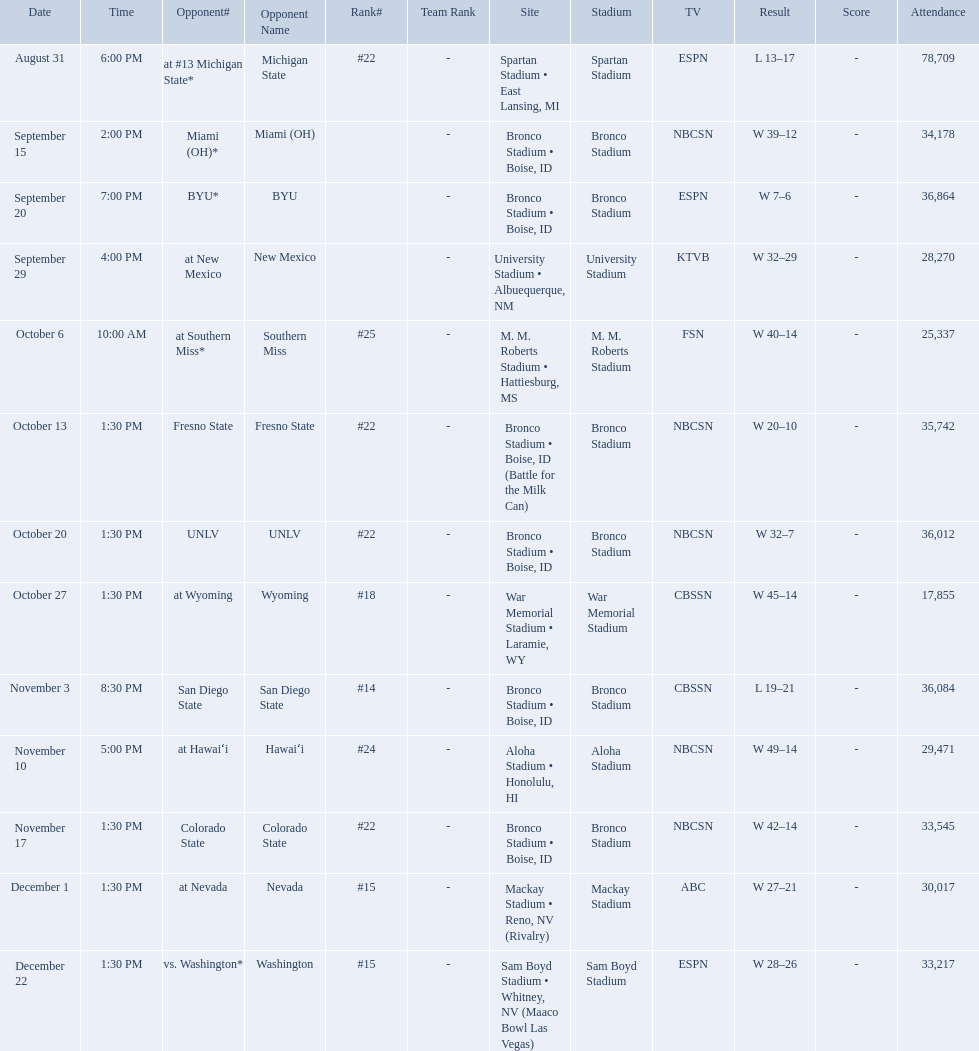What was the team's listed rankings for the season? #22, , , , #25, #22, #22, #18, #14, #24, #22, #15, #15. Which of these ranks is the best? #14. Who were all of the opponents? At #13 michigan state*, miami (oh)*, byu*, at new mexico, at southern miss*, fresno state, unlv, at wyoming, san diego state, at hawaiʻi, colorado state, at nevada, vs. washington*. Who did they face on november 3rd? San Diego State. What rank were they on november 3rd? #14. What are the opponents to the  2012 boise state broncos football team? At #13 michigan state*, miami (oh)*, byu*, at new mexico, at southern miss*, fresno state, unlv, at wyoming, san diego state, at hawaiʻi, colorado state, at nevada, vs. washington*. Which is the highest ranked of the teams? San Diego State. Who were all the opponents for boise state? At #13 michigan state*, miami (oh)*, byu*, at new mexico, at southern miss*, fresno state, unlv, at wyoming, san diego state, at hawaiʻi, colorado state, at nevada, vs. washington*. Which opponents were ranked? At #13 michigan state*, #22, at southern miss*, #25, fresno state, #22, unlv, #22, at wyoming, #18, san diego state, #14. Which opponent had the highest rank? San Diego State. 